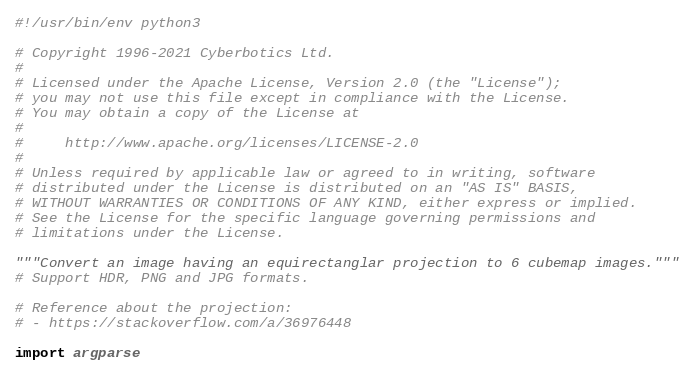<code> <loc_0><loc_0><loc_500><loc_500><_Python_>#!/usr/bin/env python3

# Copyright 1996-2021 Cyberbotics Ltd.
#
# Licensed under the Apache License, Version 2.0 (the "License");
# you may not use this file except in compliance with the License.
# You may obtain a copy of the License at
#
#     http://www.apache.org/licenses/LICENSE-2.0
#
# Unless required by applicable law or agreed to in writing, software
# distributed under the License is distributed on an "AS IS" BASIS,
# WITHOUT WARRANTIES OR CONDITIONS OF ANY KIND, either express or implied.
# See the License for the specific language governing permissions and
# limitations under the License.

"""Convert an image having an equirectanglar projection to 6 cubemap images."""
# Support HDR, PNG and JPG formats.

# Reference about the projection:
# - https://stackoverflow.com/a/36976448

import argparse</code> 